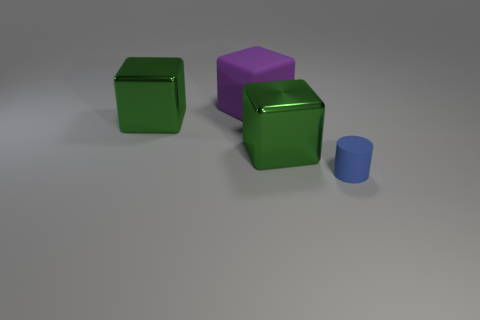There is a big green object that is to the right of the rubber object that is behind the cylinder; what shape is it?
Give a very brief answer. Cube. Are any big yellow rubber cubes visible?
Keep it short and to the point. No. What number of tiny blue objects are to the left of the rubber object behind the matte object that is on the right side of the large purple object?
Offer a terse response. 0. There is a purple rubber object; does it have the same shape as the object that is to the left of the purple rubber thing?
Offer a terse response. Yes. Is the number of blue things greater than the number of big green shiny objects?
Offer a terse response. No. Is there anything else that is the same size as the blue cylinder?
Your answer should be compact. No. Is the shape of the rubber object to the left of the tiny blue thing the same as  the small rubber thing?
Give a very brief answer. No. Are there more rubber objects that are behind the large purple rubber thing than large brown shiny objects?
Ensure brevity in your answer.  No. What is the color of the matte object that is to the left of the small blue rubber cylinder that is in front of the big rubber object?
Provide a succinct answer. Purple. How many matte cylinders are there?
Your answer should be compact. 1. 